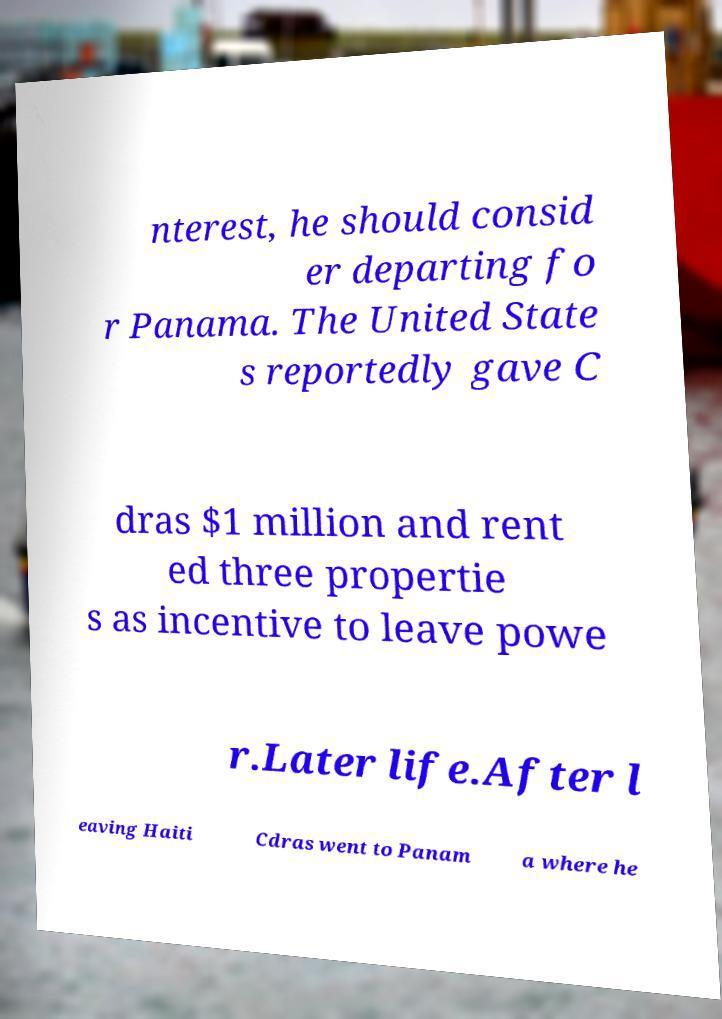There's text embedded in this image that I need extracted. Can you transcribe it verbatim? nterest, he should consid er departing fo r Panama. The United State s reportedly gave C dras $1 million and rent ed three propertie s as incentive to leave powe r.Later life.After l eaving Haiti Cdras went to Panam a where he 